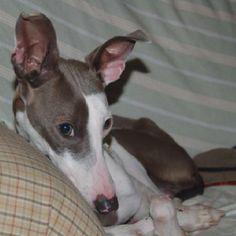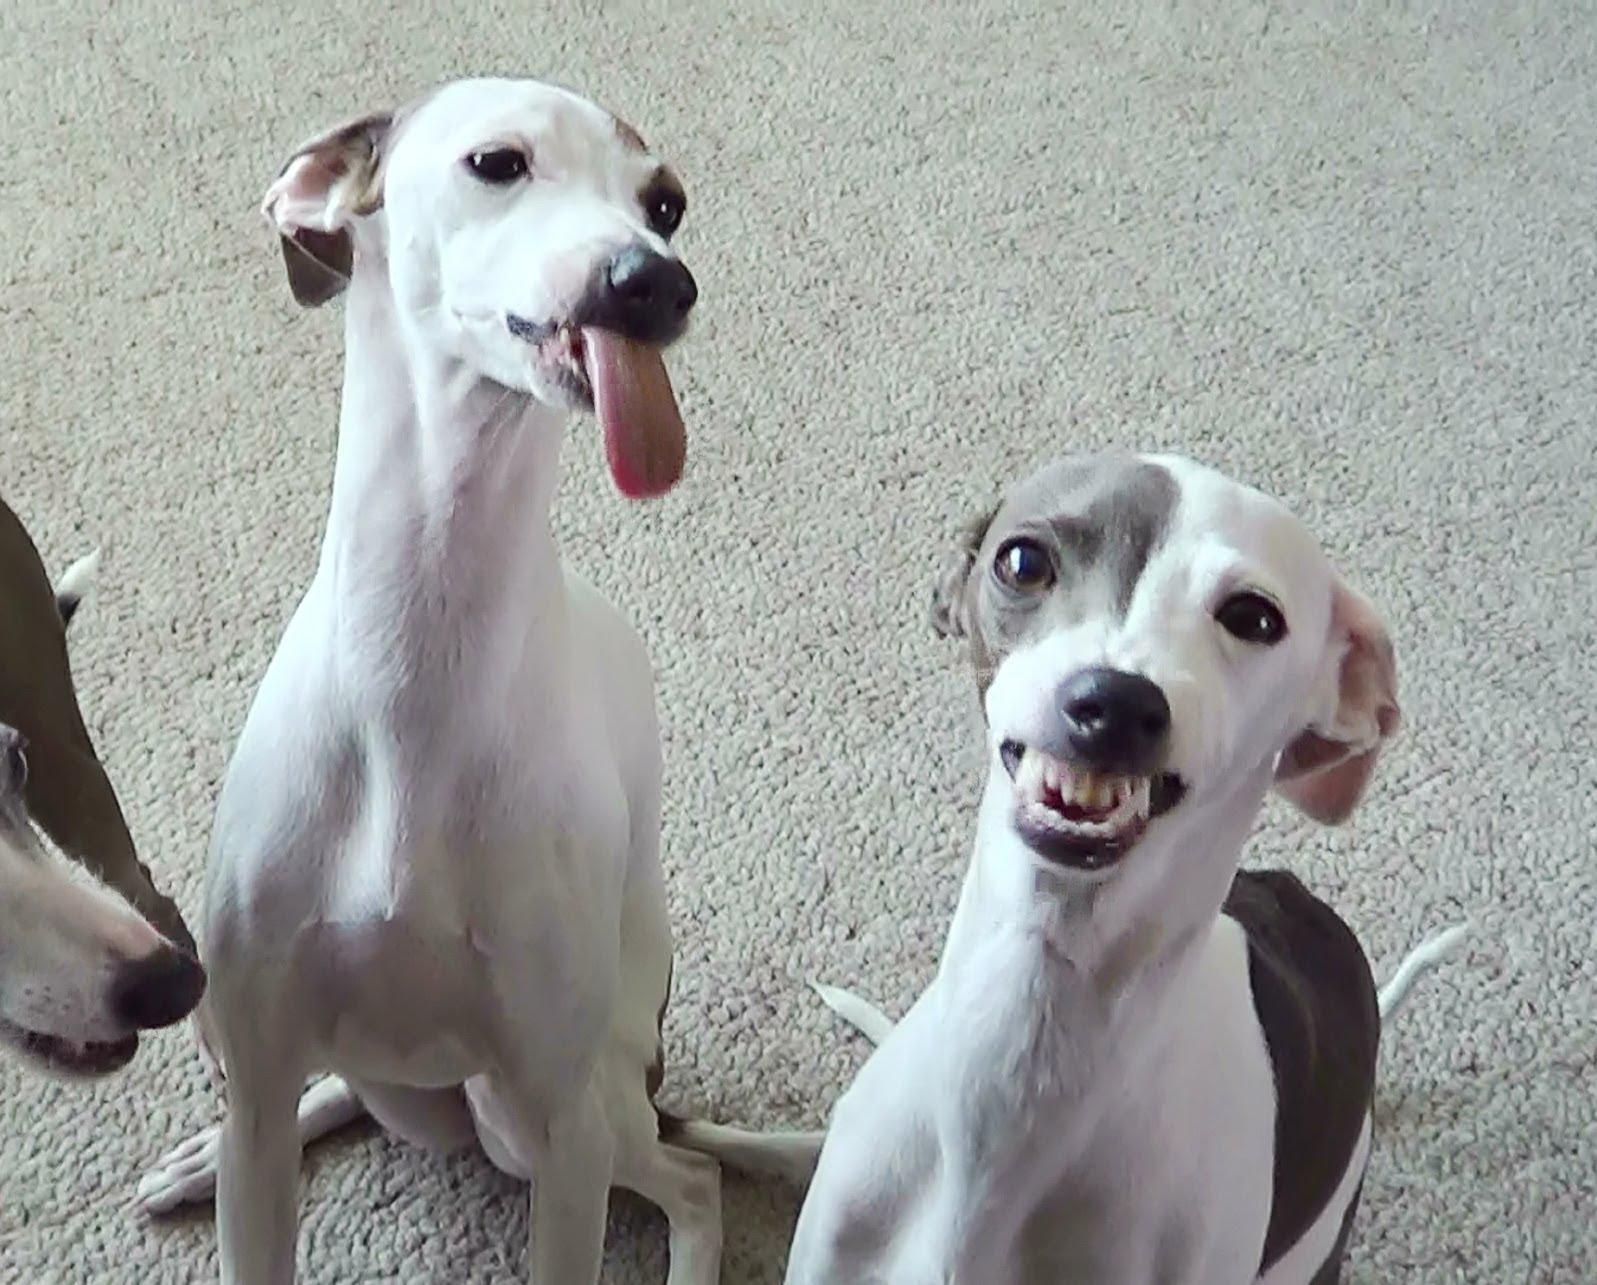The first image is the image on the left, the second image is the image on the right. Assess this claim about the two images: "An image shows just one hound, reclining with paws extended forward.". Correct or not? Answer yes or no. No. The first image is the image on the left, the second image is the image on the right. Considering the images on both sides, is "There are two dogs in total" valid? Answer yes or no. No. 